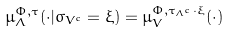Convert formula to latex. <formula><loc_0><loc_0><loc_500><loc_500>\mu _ { \Lambda } ^ { \Phi , \tau } ( \cdot | \sigma _ { V ^ { c } } = \xi ) = \mu _ { V } ^ { \Phi , { \tau _ { \Lambda ^ { c } } \cdot \xi } } ( \cdot )</formula> 